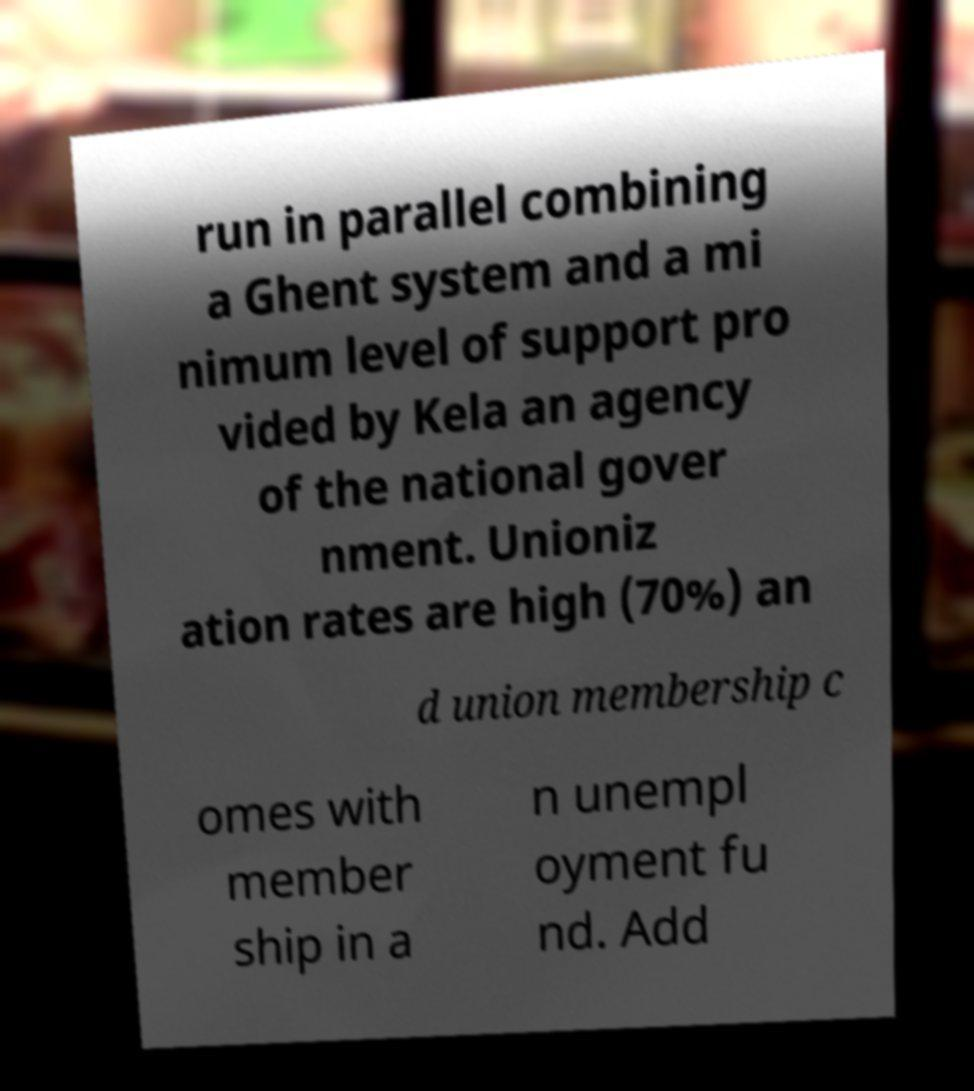I need the written content from this picture converted into text. Can you do that? run in parallel combining a Ghent system and a mi nimum level of support pro vided by Kela an agency of the national gover nment. Unioniz ation rates are high (70%) an d union membership c omes with member ship in a n unempl oyment fu nd. Add 